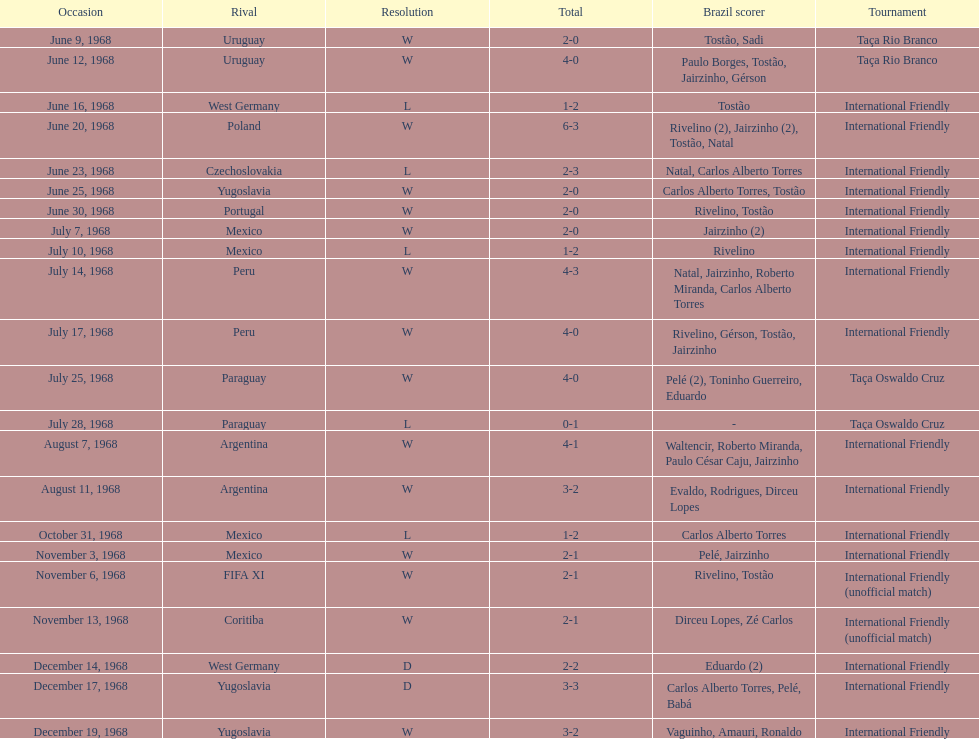What is the top score ever scored by the brazil national team? 6. Parse the full table. {'header': ['Occasion', 'Rival', 'Resolution', 'Total', 'Brazil scorer', 'Tournament'], 'rows': [['June 9, 1968', 'Uruguay', 'W', '2-0', 'Tostão, Sadi', 'Taça Rio Branco'], ['June 12, 1968', 'Uruguay', 'W', '4-0', 'Paulo Borges, Tostão, Jairzinho, Gérson', 'Taça Rio Branco'], ['June 16, 1968', 'West Germany', 'L', '1-2', 'Tostão', 'International Friendly'], ['June 20, 1968', 'Poland', 'W', '6-3', 'Rivelino (2), Jairzinho (2), Tostão, Natal', 'International Friendly'], ['June 23, 1968', 'Czechoslovakia', 'L', '2-3', 'Natal, Carlos Alberto Torres', 'International Friendly'], ['June 25, 1968', 'Yugoslavia', 'W', '2-0', 'Carlos Alberto Torres, Tostão', 'International Friendly'], ['June 30, 1968', 'Portugal', 'W', '2-0', 'Rivelino, Tostão', 'International Friendly'], ['July 7, 1968', 'Mexico', 'W', '2-0', 'Jairzinho (2)', 'International Friendly'], ['July 10, 1968', 'Mexico', 'L', '1-2', 'Rivelino', 'International Friendly'], ['July 14, 1968', 'Peru', 'W', '4-3', 'Natal, Jairzinho, Roberto Miranda, Carlos Alberto Torres', 'International Friendly'], ['July 17, 1968', 'Peru', 'W', '4-0', 'Rivelino, Gérson, Tostão, Jairzinho', 'International Friendly'], ['July 25, 1968', 'Paraguay', 'W', '4-0', 'Pelé (2), Toninho Guerreiro, Eduardo', 'Taça Oswaldo Cruz'], ['July 28, 1968', 'Paraguay', 'L', '0-1', '-', 'Taça Oswaldo Cruz'], ['August 7, 1968', 'Argentina', 'W', '4-1', 'Waltencir, Roberto Miranda, Paulo César Caju, Jairzinho', 'International Friendly'], ['August 11, 1968', 'Argentina', 'W', '3-2', 'Evaldo, Rodrigues, Dirceu Lopes', 'International Friendly'], ['October 31, 1968', 'Mexico', 'L', '1-2', 'Carlos Alberto Torres', 'International Friendly'], ['November 3, 1968', 'Mexico', 'W', '2-1', 'Pelé, Jairzinho', 'International Friendly'], ['November 6, 1968', 'FIFA XI', 'W', '2-1', 'Rivelino, Tostão', 'International Friendly (unofficial match)'], ['November 13, 1968', 'Coritiba', 'W', '2-1', 'Dirceu Lopes, Zé Carlos', 'International Friendly (unofficial match)'], ['December 14, 1968', 'West Germany', 'D', '2-2', 'Eduardo (2)', 'International Friendly'], ['December 17, 1968', 'Yugoslavia', 'D', '3-3', 'Carlos Alberto Torres, Pelé, Babá', 'International Friendly'], ['December 19, 1968', 'Yugoslavia', 'W', '3-2', 'Vaguinho, Amauri, Ronaldo', 'International Friendly']]} 